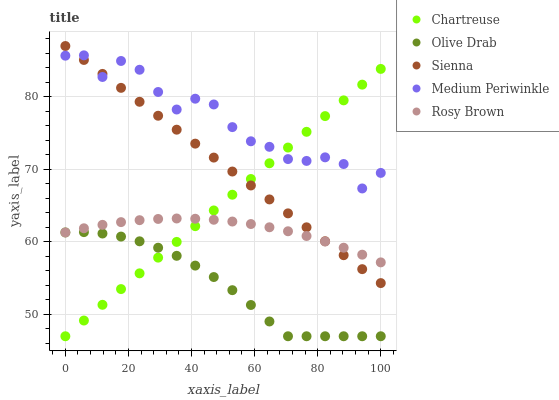Does Olive Drab have the minimum area under the curve?
Answer yes or no. Yes. Does Medium Periwinkle have the maximum area under the curve?
Answer yes or no. Yes. Does Chartreuse have the minimum area under the curve?
Answer yes or no. No. Does Chartreuse have the maximum area under the curve?
Answer yes or no. No. Is Chartreuse the smoothest?
Answer yes or no. Yes. Is Medium Periwinkle the roughest?
Answer yes or no. Yes. Is Rosy Brown the smoothest?
Answer yes or no. No. Is Rosy Brown the roughest?
Answer yes or no. No. Does Chartreuse have the lowest value?
Answer yes or no. Yes. Does Rosy Brown have the lowest value?
Answer yes or no. No. Does Sienna have the highest value?
Answer yes or no. Yes. Does Chartreuse have the highest value?
Answer yes or no. No. Is Olive Drab less than Sienna?
Answer yes or no. Yes. Is Medium Periwinkle greater than Olive Drab?
Answer yes or no. Yes. Does Chartreuse intersect Medium Periwinkle?
Answer yes or no. Yes. Is Chartreuse less than Medium Periwinkle?
Answer yes or no. No. Is Chartreuse greater than Medium Periwinkle?
Answer yes or no. No. Does Olive Drab intersect Sienna?
Answer yes or no. No. 